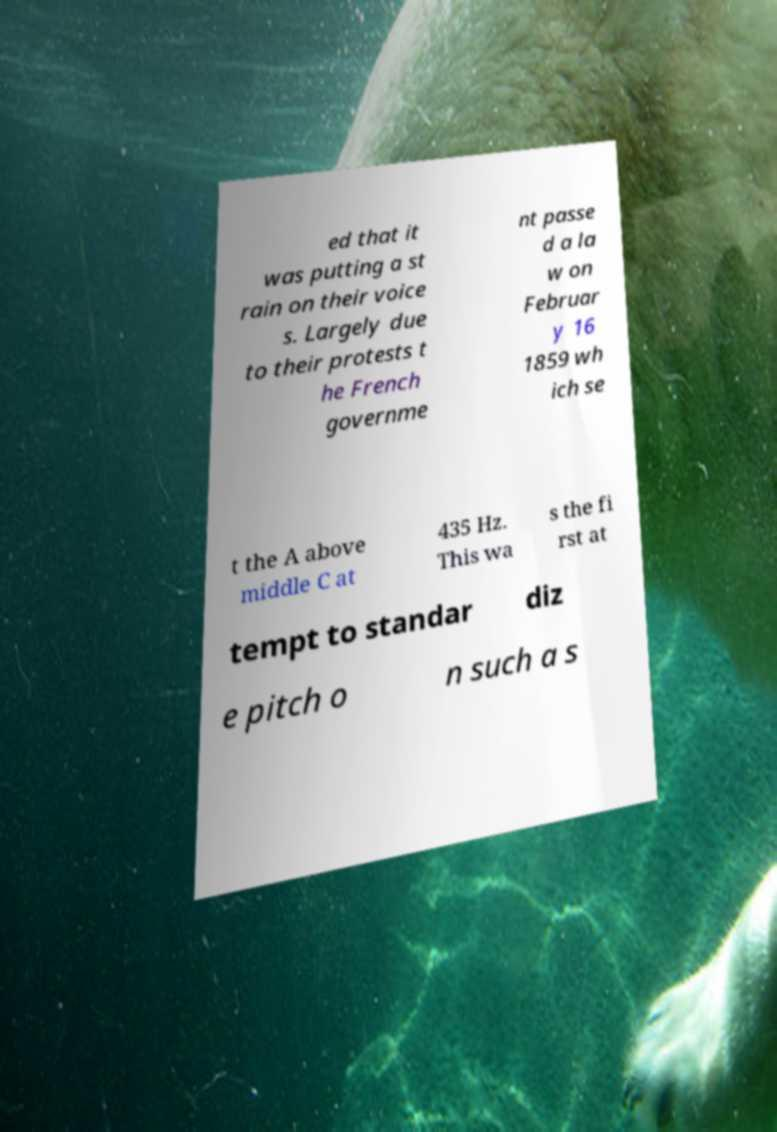What messages or text are displayed in this image? I need them in a readable, typed format. ed that it was putting a st rain on their voice s. Largely due to their protests t he French governme nt passe d a la w on Februar y 16 1859 wh ich se t the A above middle C at 435 Hz. This wa s the fi rst at tempt to standar diz e pitch o n such a s 